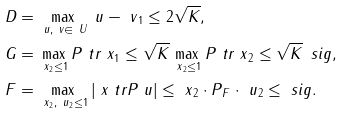<formula> <loc_0><loc_0><loc_500><loc_500>D & = \max _ { \ u , \ v \in \ U } \| \ u - \ v \| _ { 1 } \leq 2 \sqrt { K } , \\ G & = \max _ { \| \ x \| _ { 2 } \leq 1 } \| P \ t r \ x \| _ { 1 } \leq \sqrt { K } \max _ { \| \ x \| _ { 2 } \leq 1 } \| P \ t r \ x \| _ { 2 } \leq \sqrt { K } \, \ s i g , \\ F & = \max _ { \| \ x \| _ { 2 } , \| \ u \| _ { 2 } \leq 1 } | \ x \ t r P \ u | \leq \| \ x \| _ { 2 } \cdot \| P \| _ { F } \cdot \| \ u \| _ { 2 } \leq \ s i g .</formula> 